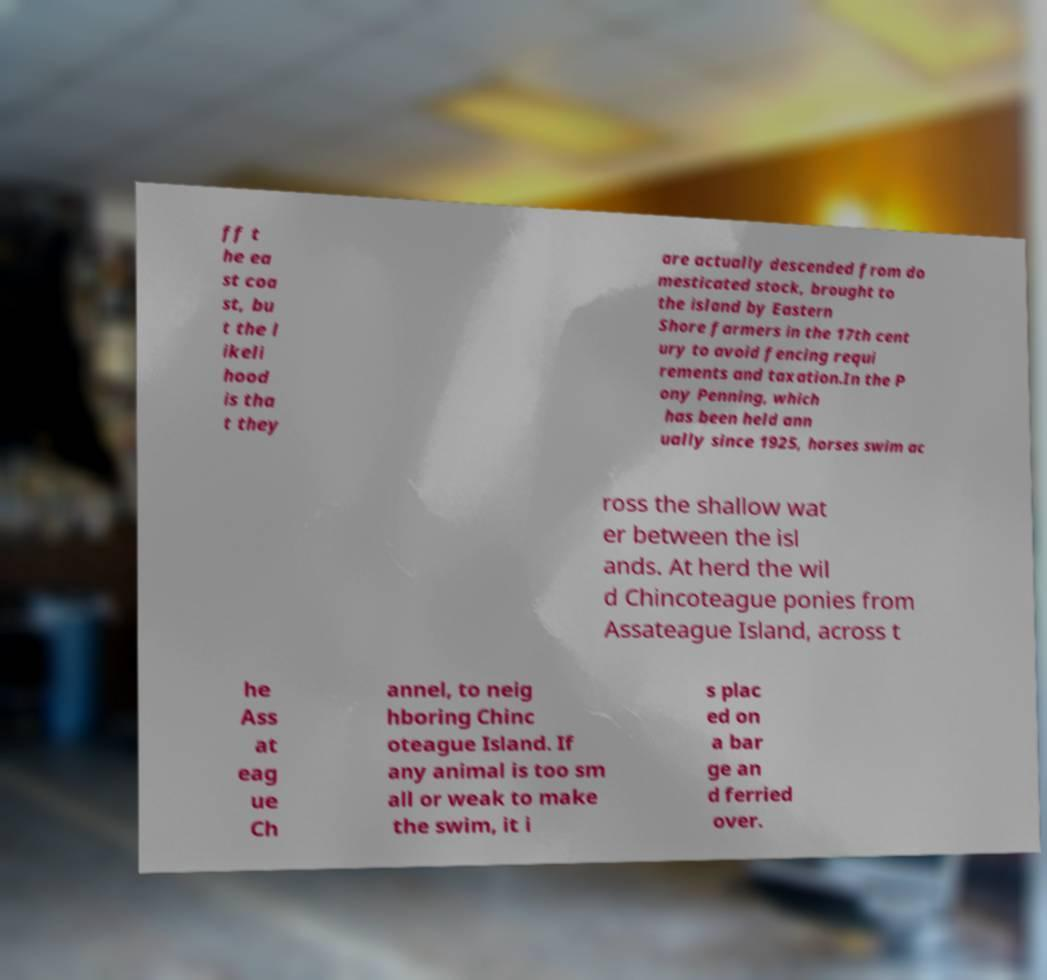I need the written content from this picture converted into text. Can you do that? ff t he ea st coa st, bu t the l ikeli hood is tha t they are actually descended from do mesticated stock, brought to the island by Eastern Shore farmers in the 17th cent ury to avoid fencing requi rements and taxation.In the P ony Penning, which has been held ann ually since 1925, horses swim ac ross the shallow wat er between the isl ands. At herd the wil d Chincoteague ponies from Assateague Island, across t he Ass at eag ue Ch annel, to neig hboring Chinc oteague Island. If any animal is too sm all or weak to make the swim, it i s plac ed on a bar ge an d ferried over. 